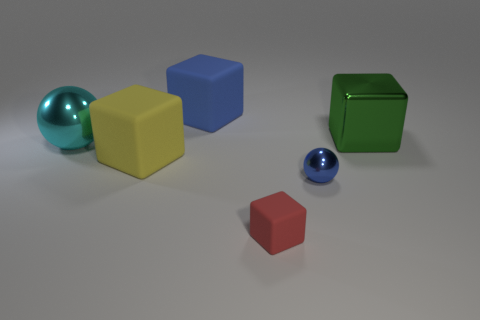Add 4 small green shiny cubes. How many objects exist? 10 Subtract all cubes. How many objects are left? 2 Add 2 large green shiny things. How many large green shiny things are left? 3 Add 2 small brown objects. How many small brown objects exist? 2 Subtract 0 yellow spheres. How many objects are left? 6 Subtract all large red rubber things. Subtract all metal spheres. How many objects are left? 4 